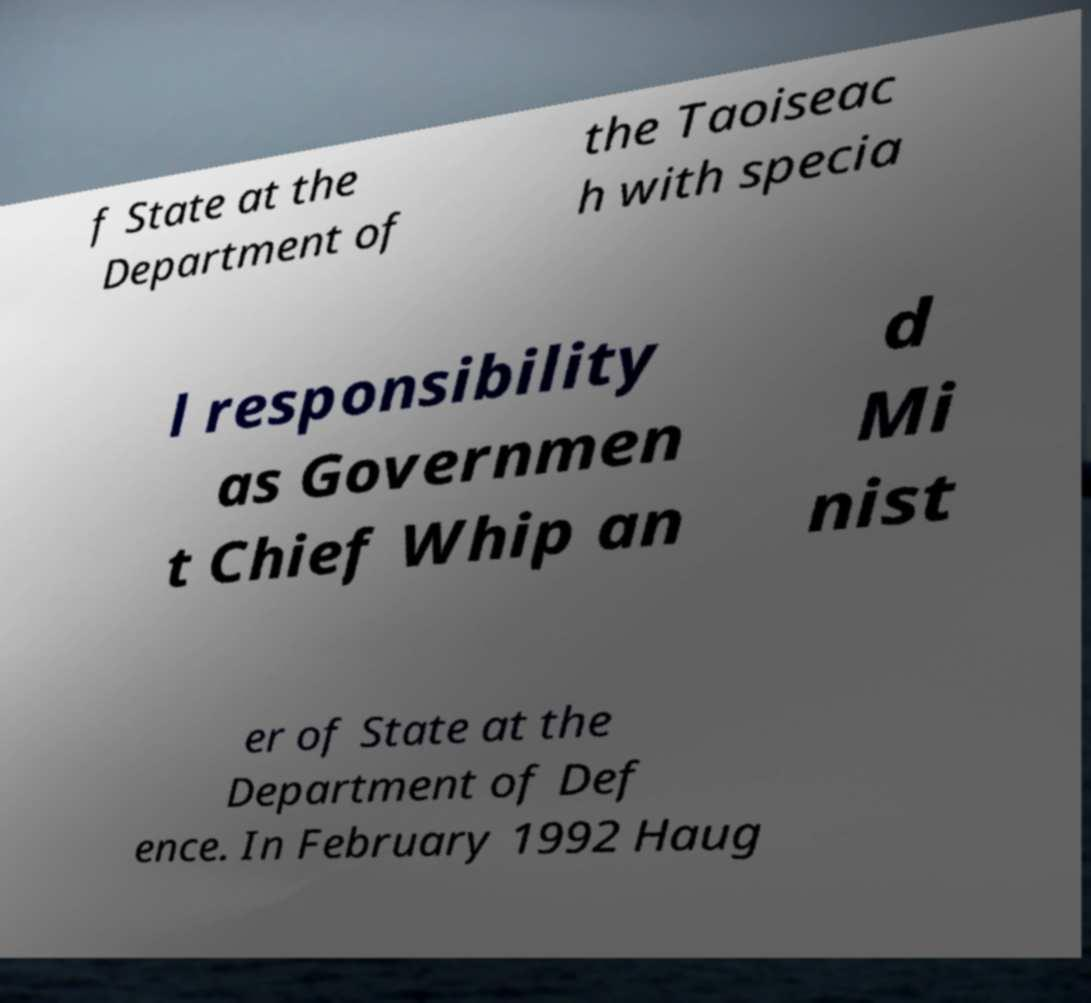I need the written content from this picture converted into text. Can you do that? f State at the Department of the Taoiseac h with specia l responsibility as Governmen t Chief Whip an d Mi nist er of State at the Department of Def ence. In February 1992 Haug 